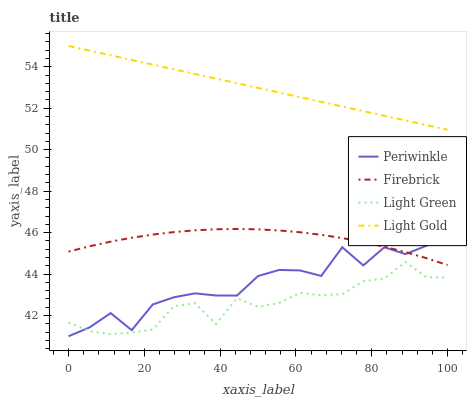Does Light Green have the minimum area under the curve?
Answer yes or no. Yes. Does Light Gold have the maximum area under the curve?
Answer yes or no. Yes. Does Firebrick have the minimum area under the curve?
Answer yes or no. No. Does Firebrick have the maximum area under the curve?
Answer yes or no. No. Is Light Gold the smoothest?
Answer yes or no. Yes. Is Periwinkle the roughest?
Answer yes or no. Yes. Is Firebrick the smoothest?
Answer yes or no. No. Is Firebrick the roughest?
Answer yes or no. No. Does Periwinkle have the lowest value?
Answer yes or no. Yes. Does Firebrick have the lowest value?
Answer yes or no. No. Does Light Gold have the highest value?
Answer yes or no. Yes. Does Firebrick have the highest value?
Answer yes or no. No. Is Light Green less than Firebrick?
Answer yes or no. Yes. Is Light Gold greater than Light Green?
Answer yes or no. Yes. Does Light Green intersect Periwinkle?
Answer yes or no. Yes. Is Light Green less than Periwinkle?
Answer yes or no. No. Is Light Green greater than Periwinkle?
Answer yes or no. No. Does Light Green intersect Firebrick?
Answer yes or no. No. 